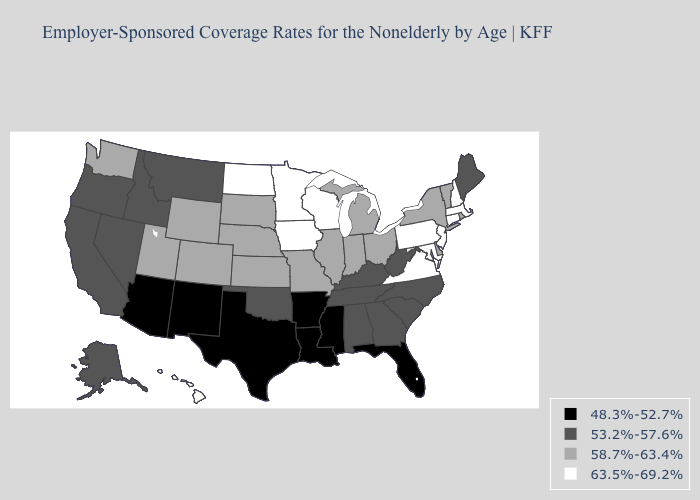Name the states that have a value in the range 63.5%-69.2%?
Give a very brief answer. Connecticut, Hawaii, Iowa, Maryland, Massachusetts, Minnesota, New Hampshire, New Jersey, North Dakota, Pennsylvania, Virginia, Wisconsin. Does Georgia have the same value as Montana?
Concise answer only. Yes. What is the highest value in the MidWest ?
Answer briefly. 63.5%-69.2%. Name the states that have a value in the range 48.3%-52.7%?
Keep it brief. Arizona, Arkansas, Florida, Louisiana, Mississippi, New Mexico, Texas. Among the states that border Alabama , which have the lowest value?
Be succinct. Florida, Mississippi. Does the map have missing data?
Quick response, please. No. What is the value of Wisconsin?
Short answer required. 63.5%-69.2%. Name the states that have a value in the range 48.3%-52.7%?
Keep it brief. Arizona, Arkansas, Florida, Louisiana, Mississippi, New Mexico, Texas. Does the first symbol in the legend represent the smallest category?
Be succinct. Yes. What is the lowest value in the USA?
Quick response, please. 48.3%-52.7%. Among the states that border Virginia , which have the highest value?
Give a very brief answer. Maryland. What is the highest value in the USA?
Keep it brief. 63.5%-69.2%. Which states have the lowest value in the MidWest?
Be succinct. Illinois, Indiana, Kansas, Michigan, Missouri, Nebraska, Ohio, South Dakota. Name the states that have a value in the range 53.2%-57.6%?
Be succinct. Alabama, Alaska, California, Georgia, Idaho, Kentucky, Maine, Montana, Nevada, North Carolina, Oklahoma, Oregon, South Carolina, Tennessee, West Virginia. What is the value of Idaho?
Be succinct. 53.2%-57.6%. 